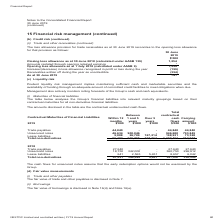From Nextdc's financial document, What were the maturity groupings of the Group's financial liabilities? The document contains multiple relevant values: Within 12 months, Between 1 and 5 years, Over 5 years. From the document: "Between 1 and 5 years Over 5 years Between 1 and 5 years Over 5 years Contractual Maturities of Financial Liabilities Within 12 months..." Also, What was the assumption behind the cash flows for unsecured notes? the early redemption options would not be exercised by the Group.. The document states: "The cash flows for unsecured notes assume that the early redemption options would not be exercised by the Group...." Also, What was the value of lease liabilities maturing between 1 and 5 years in 2019? According to the financial document, 26,709 (in thousands). The relevant text states: "900,046 - 946,680 793,849 Lease liabilities 5,008 26,709 167,214 198,931 73,328 Total non-derivatives 96,482 926,755 167,214 1,190,451 912,017..." Additionally, Which financial liabilities in 2019, maturing within 12 months, was the greatest? According to the financial document, Unsecured notes. The relevant text states: "Trade payables 44,840 - - 44,840 44,840 Unsecured notes 46,634 900,046 - 946,680 793,849 Lease liabilities 5,008 26,709 167,214 198,931 73,328 Total non-de..." Also, can you calculate: What was the 2019 percentage change in carrying amount of total non-derivatives? To answer this question, I need to perform calculations using the financial data. The calculation is: (912,017 - 330,594) / 330,594 , which equals 175.87 (percentage). This is based on the information: "otal non-derivatives 47,031 344,565 5,451 397,047 330,594 non-derivatives 96,482 926,755 167,214 1,190,451 912,017..." The key data points involved are: 330,594, 912,017. Also, can you calculate: What was the 2019 percentage change in total contractual cash flows of total non-derivatives? To answer this question, I need to perform calculations using the financial data. The calculation is: (1,190,451 - 397,047) / 397,047 , which equals 199.83 (percentage). This is based on the information: ",328 Total non-derivatives 96,482 926,755 167,214 1,190,451 912,017 6,042 Total non-derivatives 47,031 344,565 5,451 397,047 330,594..." The key data points involved are: 1,190,451, 397,047. 